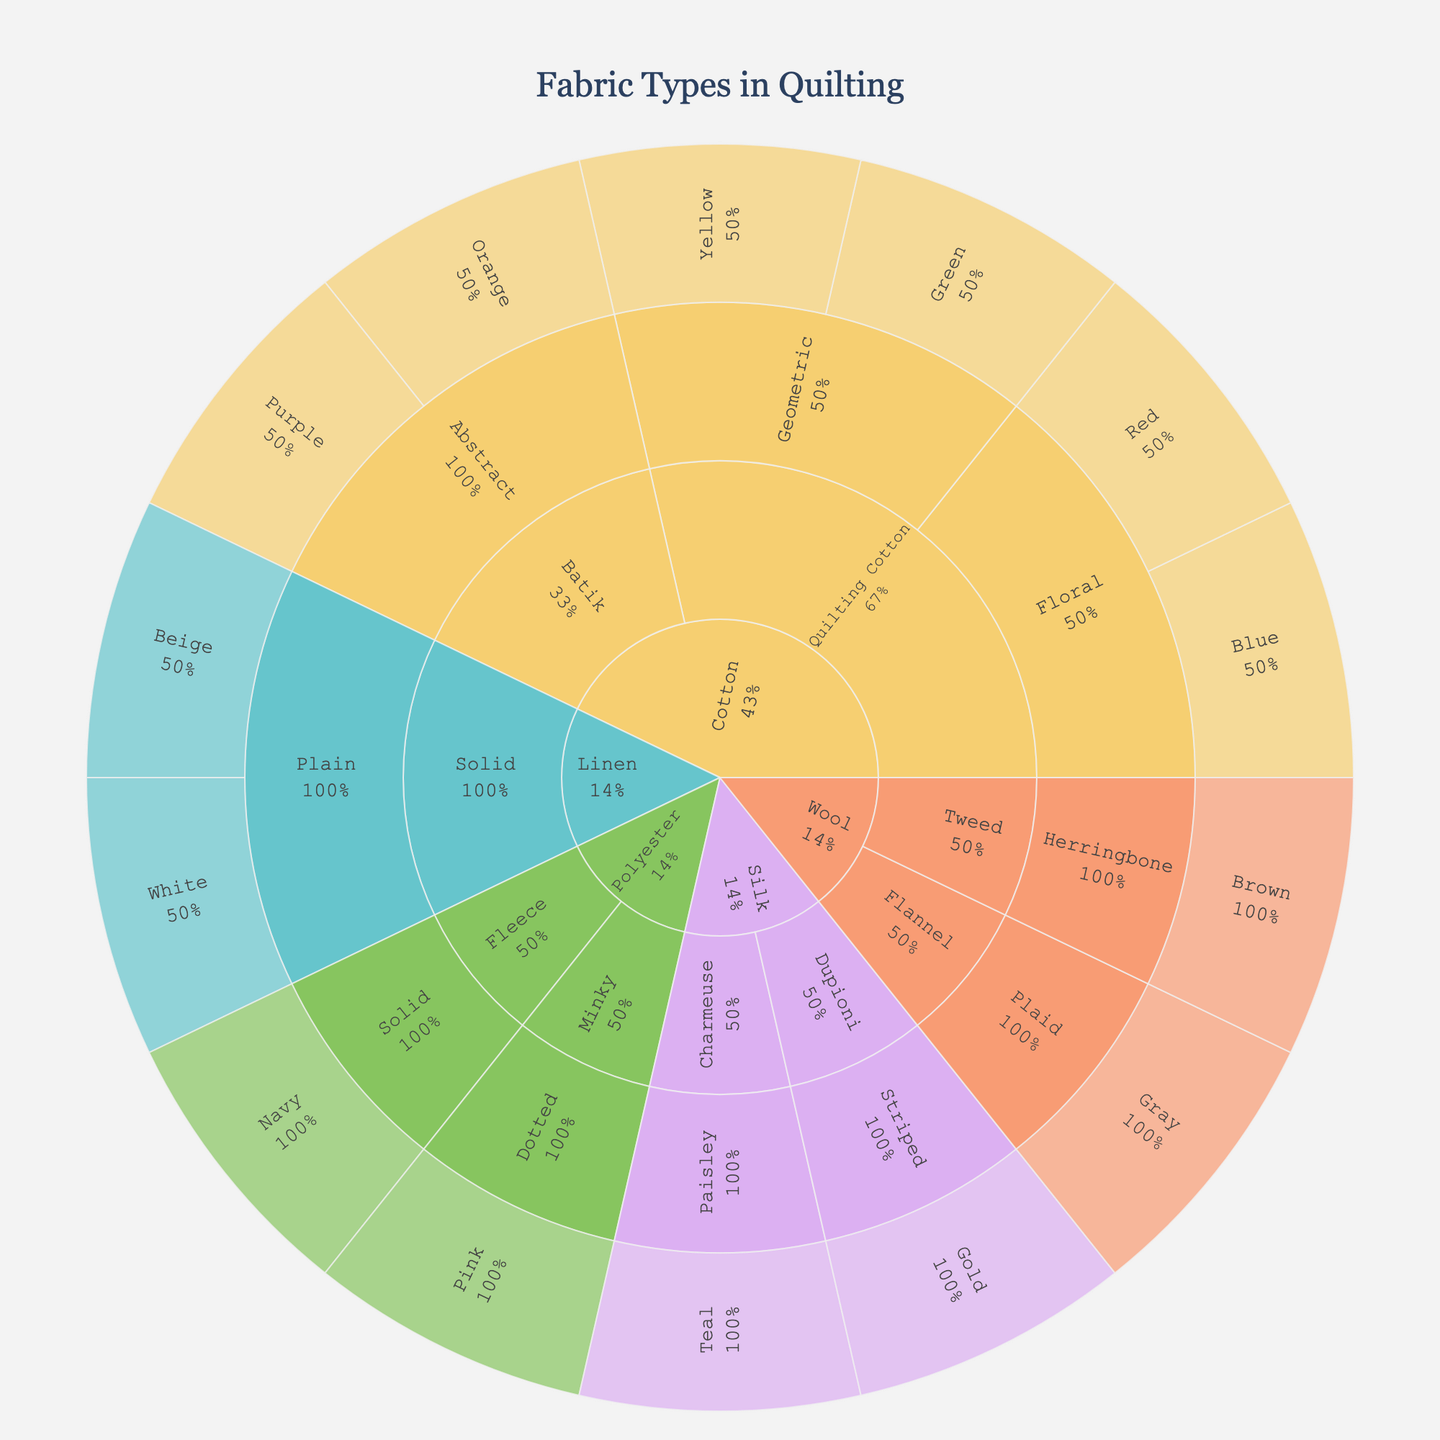What is the central theme of the Sunburst Plot? The central theme of the plot is the breakdown of fabric types used in quilting, categorized by material, type, pattern, and color palette. This is explicitly mentioned in the title of the plot.
Answer: Breakdown of fabric types in quilting Which material has the most categories under it? To find this, look at the initial divisions from the center of the Sunburst Plot. Cotton branches into several types, patterns, and colors, indicating it has the most categories.
Answer: Cotton How many total color categories are used for Linen material? From the Linen branch, we see two paths, each representing a color. So, there are 2 color categories used for Linen.
Answer: 2 Which colors are used under the 'Floral' pattern in 'Quilting Cotton'? By tracing the path within 'Quilting Cotton' and then 'Floral,' we see it branches further into 'Blue' and 'Red.' These are the colors used.
Answer: Blue and Red What is the percentage representation of 'Silk' within their parent 'material'? Look at the Silk branch and its percentage label to get this information. This value is calculated as the percentage of the 'Silk' section relative to its total parent section 'material.'
Answer: Percentage as shown on the plot Out of the materials 'Cotton' and 'Wool', which has a wider range of patterns? By observing the Cotton and Wool branches, Cotton has several patterns (Floral, Geometric, Abstract) whereas Wool has fewer (Plaid, Herringbone). Cotton has a wider range.
Answer: Cotton What pattern type does the Wool Herringbone classification fall under? Since patterns directly branch out from the material, we can trace the Wool branch to see that 'Herringbone' falls under the 'Tweed' type.
Answer: Tweed Compare the number of types under 'Polyester' and 'Linen.' Which has more? 'Polyester' has two types (Minky, Fleece) and 'Linen' has one (Solid). Polyester has more types.
Answer: Polyester What 'color palettes’ are used in fabrics with 'Paisley' pattern under 'Silk'? By tracing the path through Silk, then Charmeuse and finally Paisley, the color linked to this pattern is 'Teal.'
Answer: Teal How many fabric types are classified under 'Cotton' material? By observing the branches under Cotton, we see two different types: Quilting Cotton and Batik.
Answer: 2 